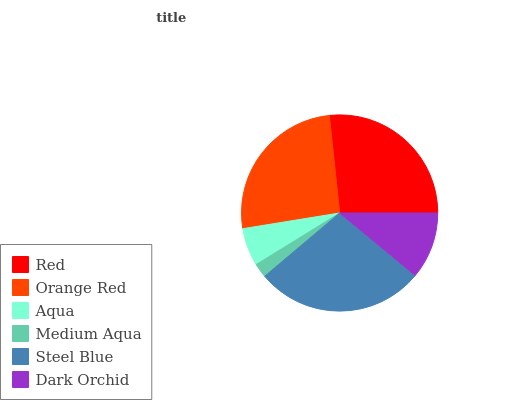Is Medium Aqua the minimum?
Answer yes or no. Yes. Is Steel Blue the maximum?
Answer yes or no. Yes. Is Orange Red the minimum?
Answer yes or no. No. Is Orange Red the maximum?
Answer yes or no. No. Is Red greater than Orange Red?
Answer yes or no. Yes. Is Orange Red less than Red?
Answer yes or no. Yes. Is Orange Red greater than Red?
Answer yes or no. No. Is Red less than Orange Red?
Answer yes or no. No. Is Orange Red the high median?
Answer yes or no. Yes. Is Dark Orchid the low median?
Answer yes or no. Yes. Is Aqua the high median?
Answer yes or no. No. Is Medium Aqua the low median?
Answer yes or no. No. 